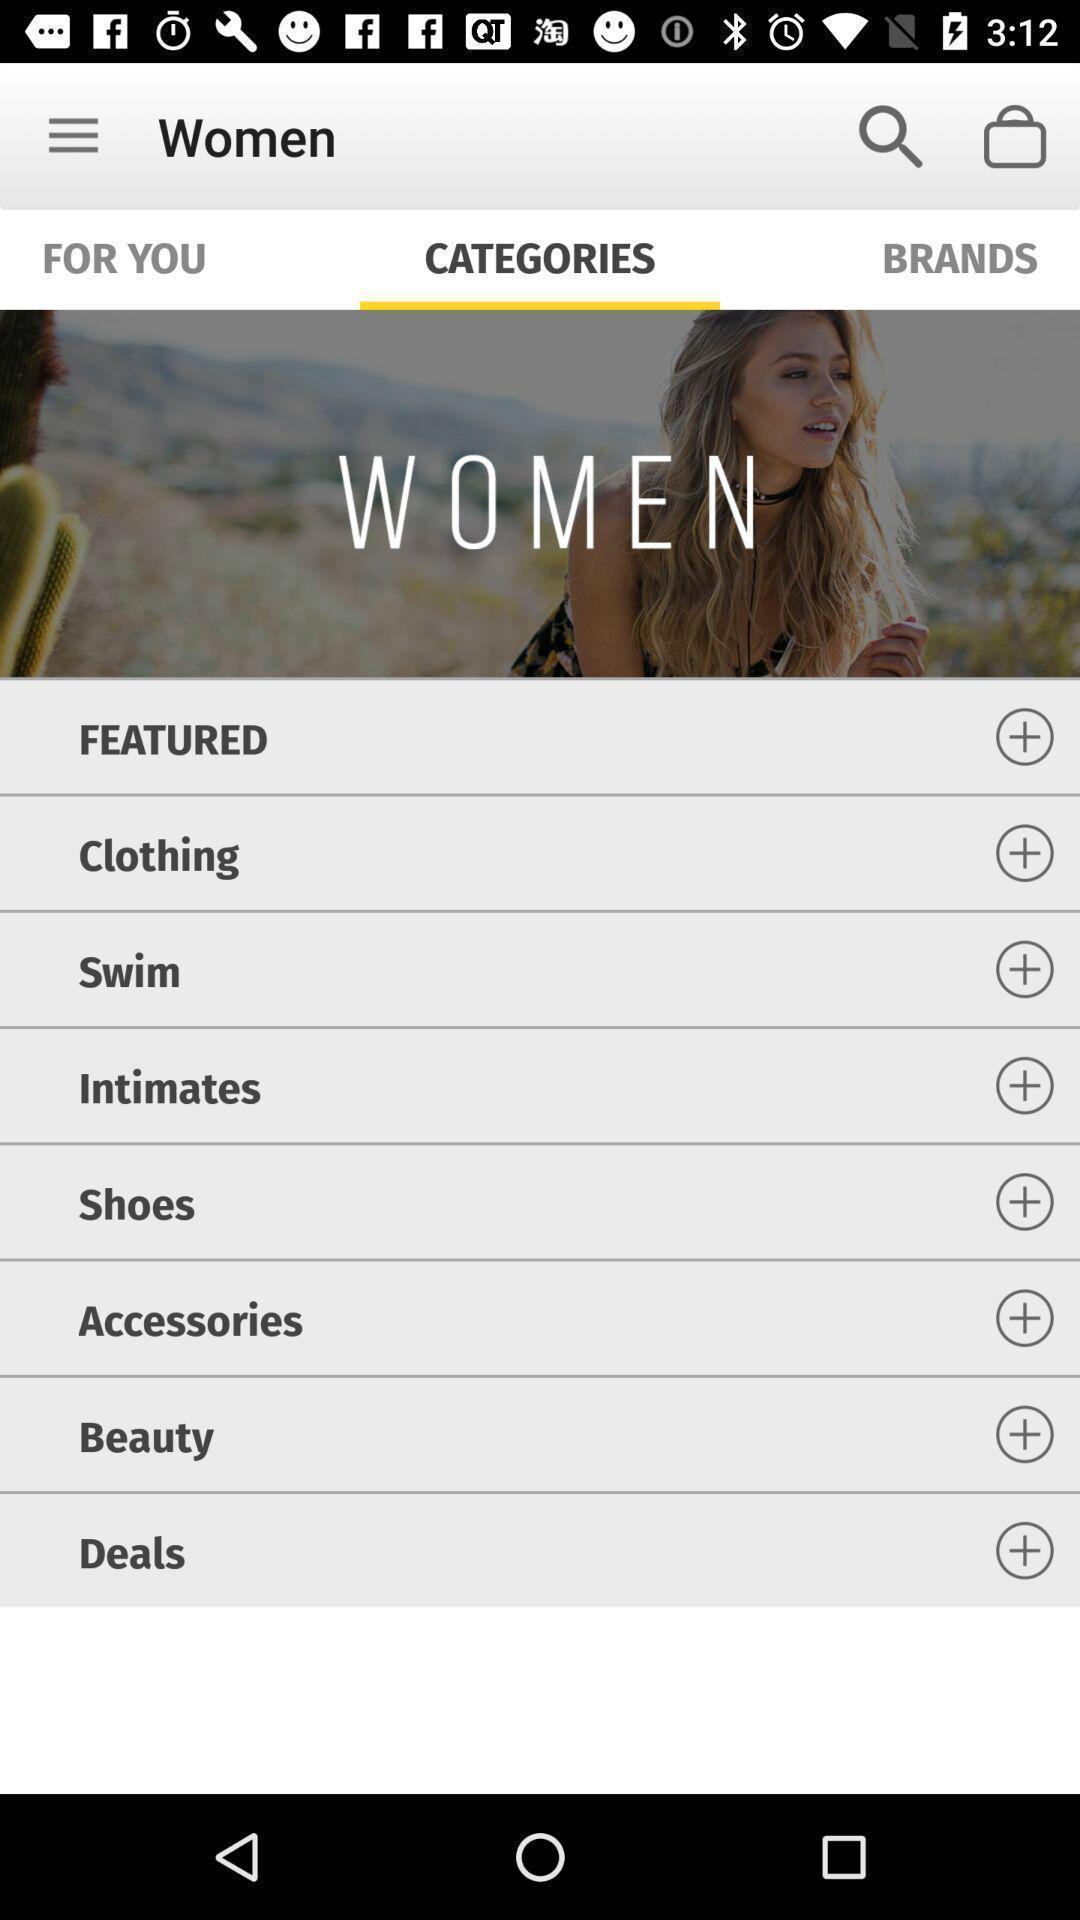Give me a summary of this screen capture. Screen showing list of various categories of a shopping app. 